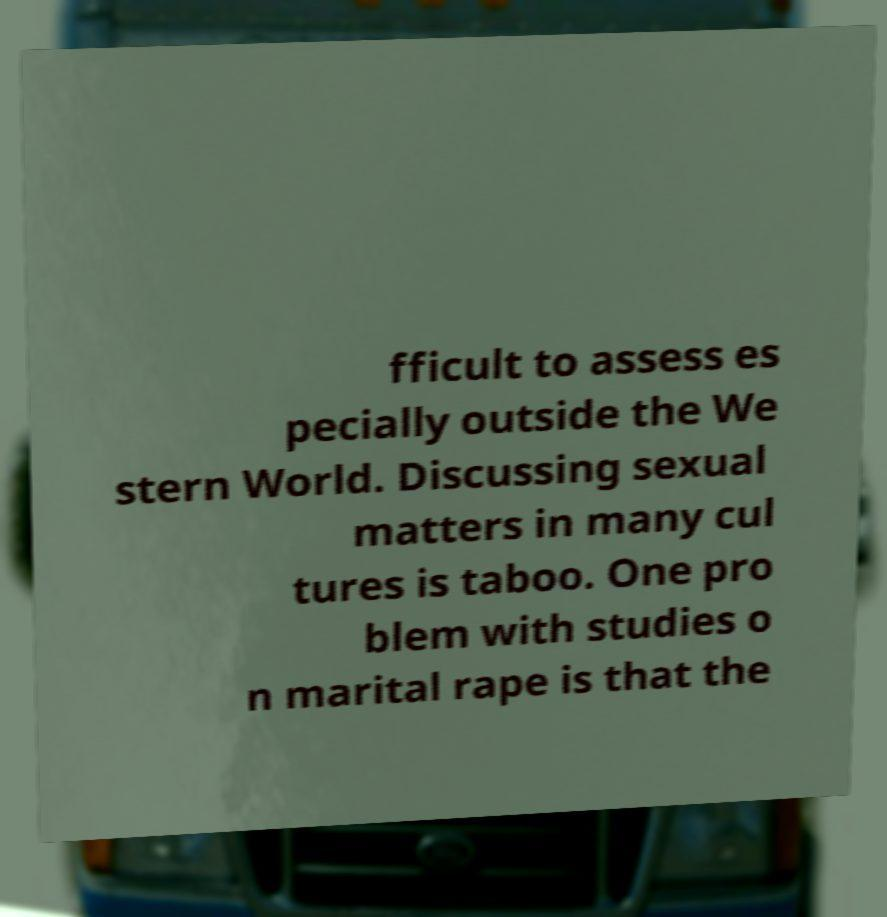There's text embedded in this image that I need extracted. Can you transcribe it verbatim? fficult to assess es pecially outside the We stern World. Discussing sexual matters in many cul tures is taboo. One pro blem with studies o n marital rape is that the 